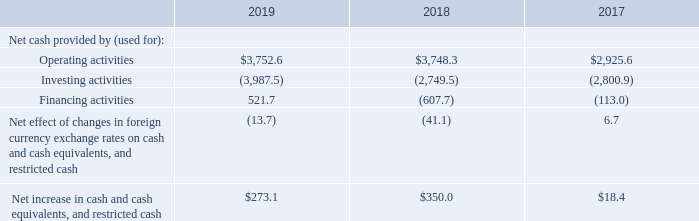Summary cash flow information is set forth below for the years ended December 31, (in millions):
We use our cash flows to fund our operations and investments in our business, including tower maintenance and improvements, communications site construction and managed network installations and tower and land acquisitions. Additionally, we use our cash flows to make distributions, including distributions of our REIT taxable income to maintain our qualification for taxation as a REIT under the Code. We may also repay or repurchase our existing indebtedness or equity from time to time. We typically fund our international expansion efforts primarily through a combination of cash on hand, intercompany debt and equity contributions.
In April 2019, Tata Teleservices and Tata Sons Limited, two of our minority holders in India, delivered notice of exercise
of their put options with respect to their remaining combined holdings in our Indian subsidiary, ATC TIPL (see note 15 to our
consolidated financial statements included in this Annual Report). Accordingly, we expect to pay an amount equivalent to INR
24.8 billion (approximately $347.6 million at the December 31, 2019 exchange rate) to redeem the put shares in the first half of
2020, subject to regulatory approval. In connection with the closing of the Eaton Towers Acquisition, 
In April 2019, Tata Teleservices and Tata Sons Limited, two of our minority holders in India, delivered notice of exercise of their put options with respect to their remaining combined holdings in our Indian subsidiary, ATC TIPL (see note 15 to our consolidated financial statements included in this Annual Report). Accordingly, we expect to pay an amount equivalent to INR 24.8 billion (approximately $347.6 million at the December 31, 2019 exchange rate) to redeem the put shares in the first half of 2020, subject to regulatory approval. In connection with the closing of the Eaton Towers Acquisition,  In April 2019, Tata Teleservices and Tata Sons Limited, two of our minority holders in India, delivered notice of exercise of their put options with respect to their remaining combined holdings in our Indian subsidiary, ATC TIPL (see note 15 to our consolidated financial statements included in this Annual Report). Accordingly, we expect to pay an amount equivalent to INR 24.8 billion (approximately $347.6 million at the December 31, 2019 exchange rate) to redeem the put shares in the first half of 2020, subject to regulatory approval. In connection with the closing of the Eaton Towers Acquisition, we entered into an agreement with MTN to acquire MTN’s noncontrolling interests in each of our joint ventures in Ghana and Uganda for total consideration of approximately $523.0 million. The transaction is expected to close in the first quarter of 2020, subject to regulatory approval and other closing conditions. In April 2019, Tata Teleservices and Tata Sons Limited, two of our minority holders in India, delivered notice of exercise of their put options with respect to their remaining combined holdings in our Indian subsidiary, ATC TIPL (see note 15 to our consolidated financial statements included in this Annual Report). Accordingly, we expect to pay an amount equivalent to INR 24.8 billion (approximately $347.6 million at the December 31, 2019 exchange rate) to redeem the put shares in the first half of 2020, subject to regulatory approval. In connection with the closing of the Eaton Towers Acquisition
As of December 31, 2019, we had total outstanding indebtedness of $24.2 billion, with a current portion of $2.9 billion. During the year ended December 31, 2019, we generated sufficient cash flow from operations to fund our capital expenditures and debt service obligations, as well as our required distributions. We believe the cash generated by operating activities during the year ending December 31, 2020, together with our borrowing capacity under our credit facilities and cash on hand, will be sufficient to fund our required distributions, capital expenditures, debt service obligations (interest and principal repayments) and signed acquisitions. As of December 31, 2019, we had $1.3 billion of cash and cash equivalents held by our foreign subsidiaries, of which $583.0 million was held by our joint ventures. While certain subsidiaries may pay us interest or principal on intercompany debt, it has not been our practice to repatriate earnings from our foreign subsidiaries primarily due to our ongoing expansion efforts and related capital needs. However, in the event that we do repatriate any funds, we may be required to accrue and pay certain taxes.
What was the net cash provided by (used for) Operating activities in 2019?
Answer scale should be: million. $3,752.6. What was the net cash provided by (used for) investing activities in 2018?
Answer scale should be: million. (2,749.5). What was the net cash provided by (used for) financing activities in 2017?
Answer scale should be: million. (113.0). What was the change in the net cash provided by (used for) by operating activities between 2018 and 2019?
Answer scale should be: million. $3,752.6-$3,748.3
Answer: 4.3. What was the change in the net cash provided by (used for) by investing activities between 2017 and 2018?
Answer scale should be: million. -2,749.5-(-2,800.9)
Answer: 51.4. What is the percentage change in the net cash provided by (used for) financing activities between 2017 and 2018?
Answer scale should be: percent. (-607.7-(-113.0))/-113.0
Answer: 437.79. 